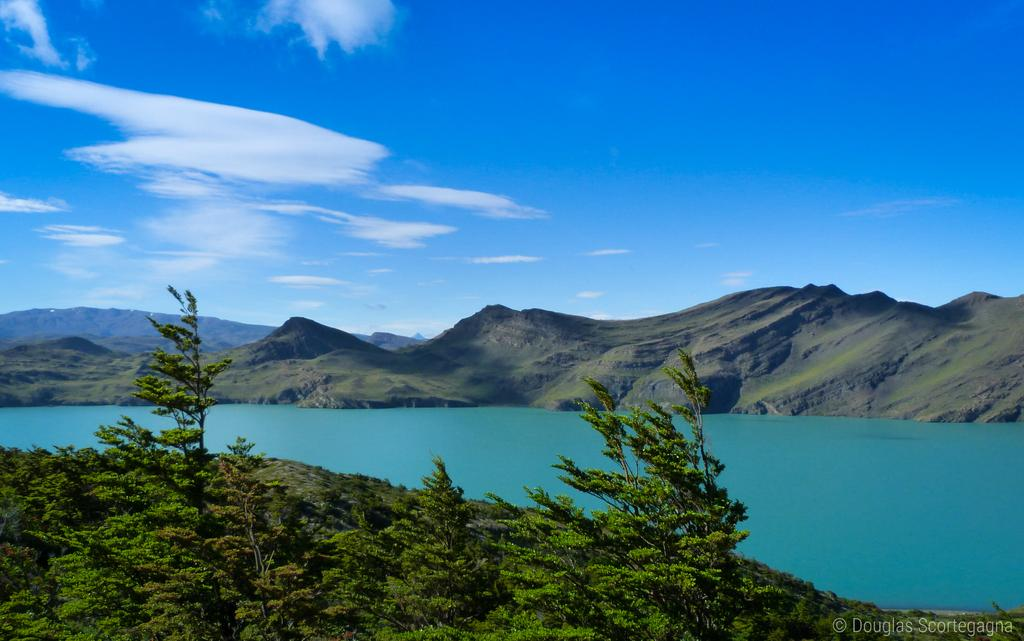What type of vegetation can be seen in the image? There are trees in the image. What is located in the center of the image? There is a lake in the center of the image. What type of geographical feature is visible in the background of the image? There are mountains in the background of the image. What is visible at the top of the image? The sky is visible at the top of the image. What can be seen in the sky in the image? Clouds are present in the sky. Can you tell me how many crayons are floating on the lake in the image? There are no crayons present in the image; it features trees, a lake, mountains, and clouds. What type of wave is depicted in the image? There is no wave depicted in the image; it features a lake, trees, mountains, and clouds. 